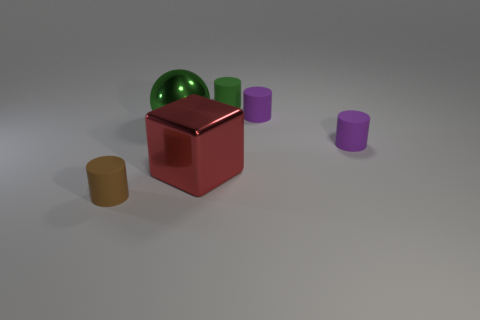Do the brown cylinder and the metallic sphere have the same size?
Your response must be concise. No. There is a tiny thing that is in front of the sphere and on the right side of the shiny block; what color is it?
Provide a short and direct response. Purple. There is a small purple cylinder that is behind the green object that is to the left of the green matte cylinder; what is it made of?
Offer a very short reply. Rubber. There is a green thing that is the same shape as the brown thing; what size is it?
Your answer should be compact. Small. Is the color of the rubber cylinder that is to the left of the small green matte thing the same as the large cube?
Offer a very short reply. No. Is the number of big red shiny things less than the number of tiny rubber things?
Make the answer very short. Yes. What number of other things are there of the same color as the big cube?
Your response must be concise. 0. Does the purple cylinder behind the green shiny sphere have the same material as the brown object?
Your answer should be very brief. Yes. What is the red thing that is in front of the big metallic sphere made of?
Keep it short and to the point. Metal. There is a matte thing left of the red metallic cube that is on the right side of the shiny sphere; what size is it?
Give a very brief answer. Small. 